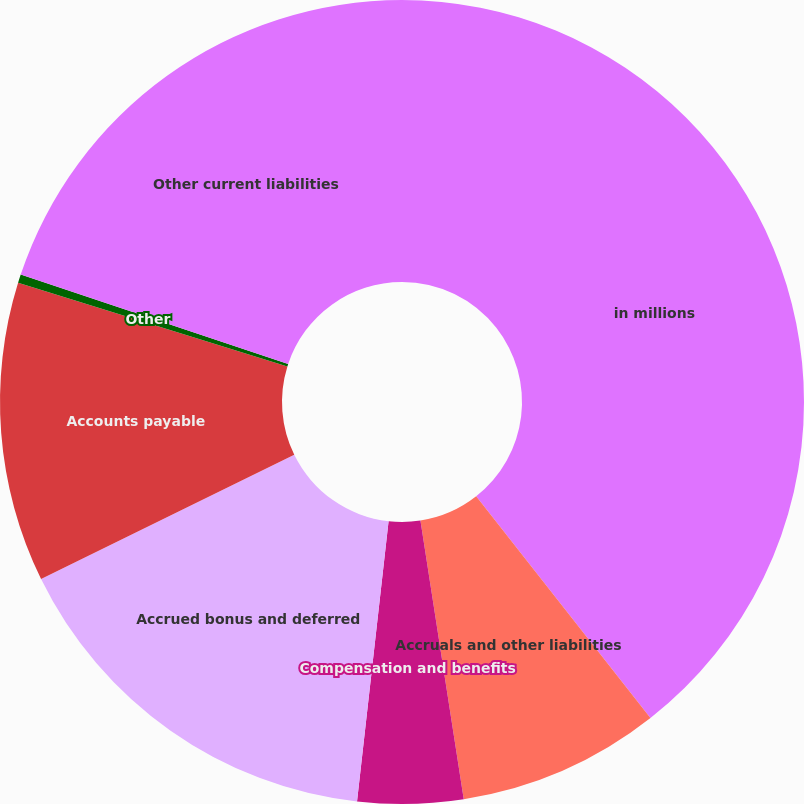Convert chart. <chart><loc_0><loc_0><loc_500><loc_500><pie_chart><fcel>in millions<fcel>Accruals and other liabilities<fcel>Compensation and benefits<fcel>Accrued bonus and deferred<fcel>Accounts payable<fcel>Other<fcel>Other current liabilities<nl><fcel>39.4%<fcel>8.15%<fcel>4.24%<fcel>15.96%<fcel>12.05%<fcel>0.34%<fcel>19.87%<nl></chart> 